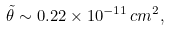<formula> <loc_0><loc_0><loc_500><loc_500>{ \tilde { \theta } } \sim 0 . 2 2 \times 1 0 ^ { - 1 1 } \, c m ^ { 2 } ,</formula> 